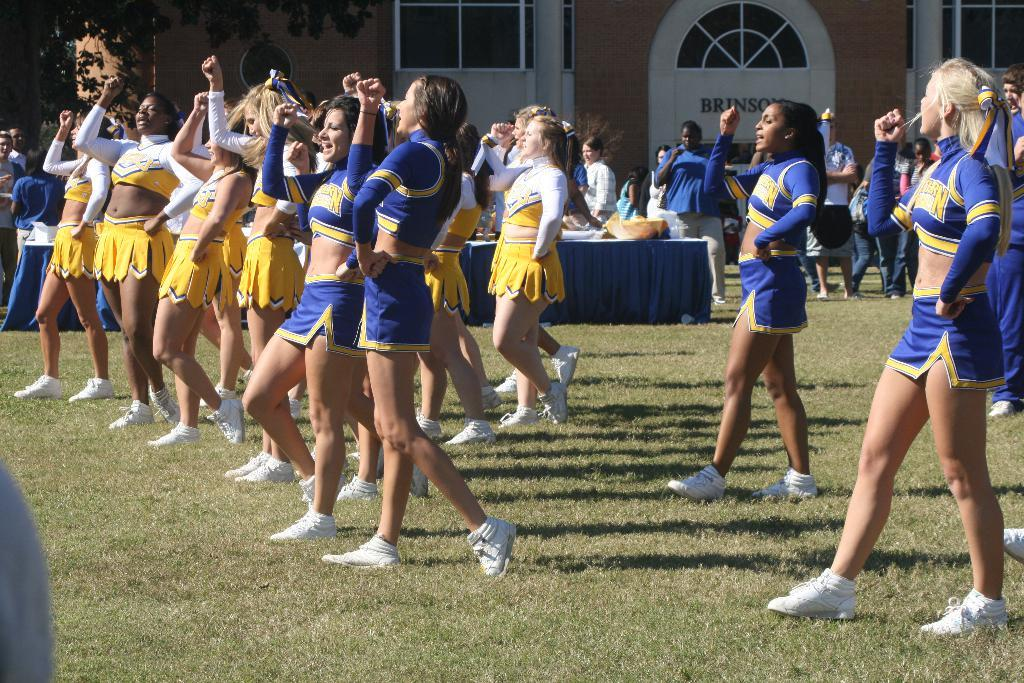<image>
Write a terse but informative summary of the picture. Many cheerleaders from LSU are lined up cheering 